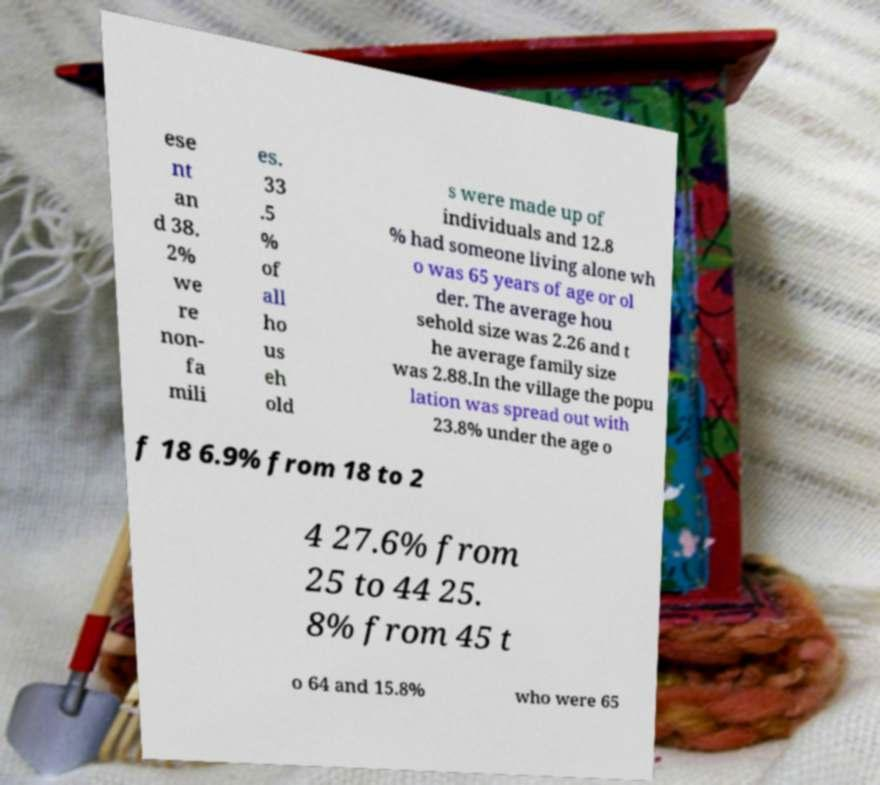Please identify and transcribe the text found in this image. ese nt an d 38. 2% we re non- fa mili es. 33 .5 % of all ho us eh old s were made up of individuals and 12.8 % had someone living alone wh o was 65 years of age or ol der. The average hou sehold size was 2.26 and t he average family size was 2.88.In the village the popu lation was spread out with 23.8% under the age o f 18 6.9% from 18 to 2 4 27.6% from 25 to 44 25. 8% from 45 t o 64 and 15.8% who were 65 